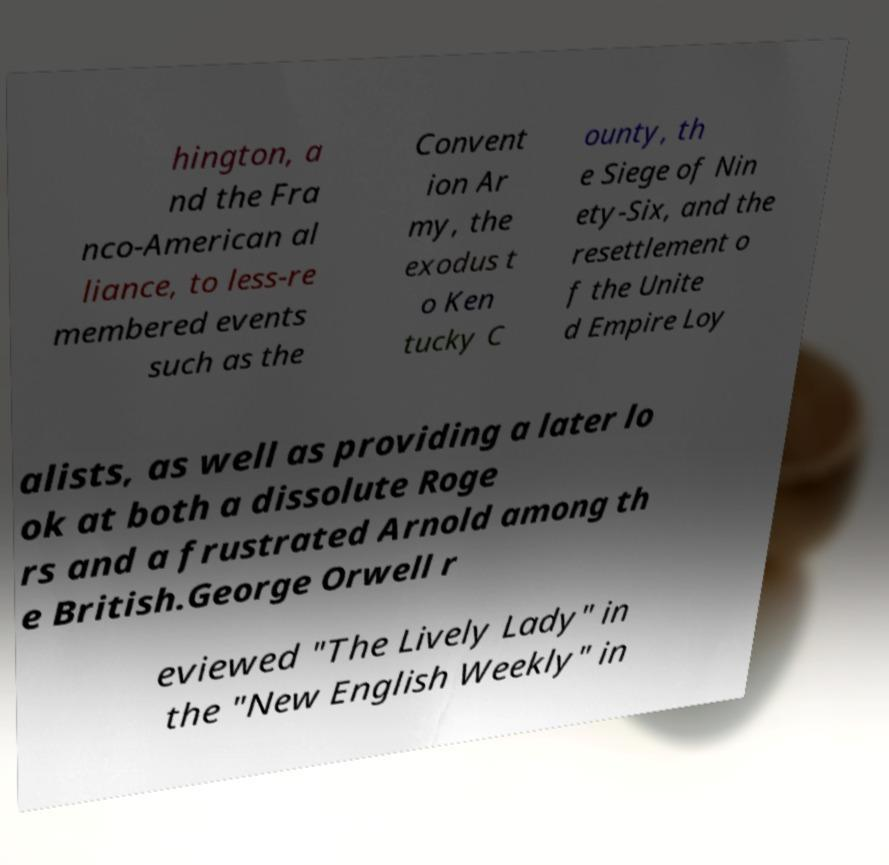There's text embedded in this image that I need extracted. Can you transcribe it verbatim? hington, a nd the Fra nco-American al liance, to less-re membered events such as the Convent ion Ar my, the exodus t o Ken tucky C ounty, th e Siege of Nin ety-Six, and the resettlement o f the Unite d Empire Loy alists, as well as providing a later lo ok at both a dissolute Roge rs and a frustrated Arnold among th e British.George Orwell r eviewed "The Lively Lady" in the "New English Weekly" in 